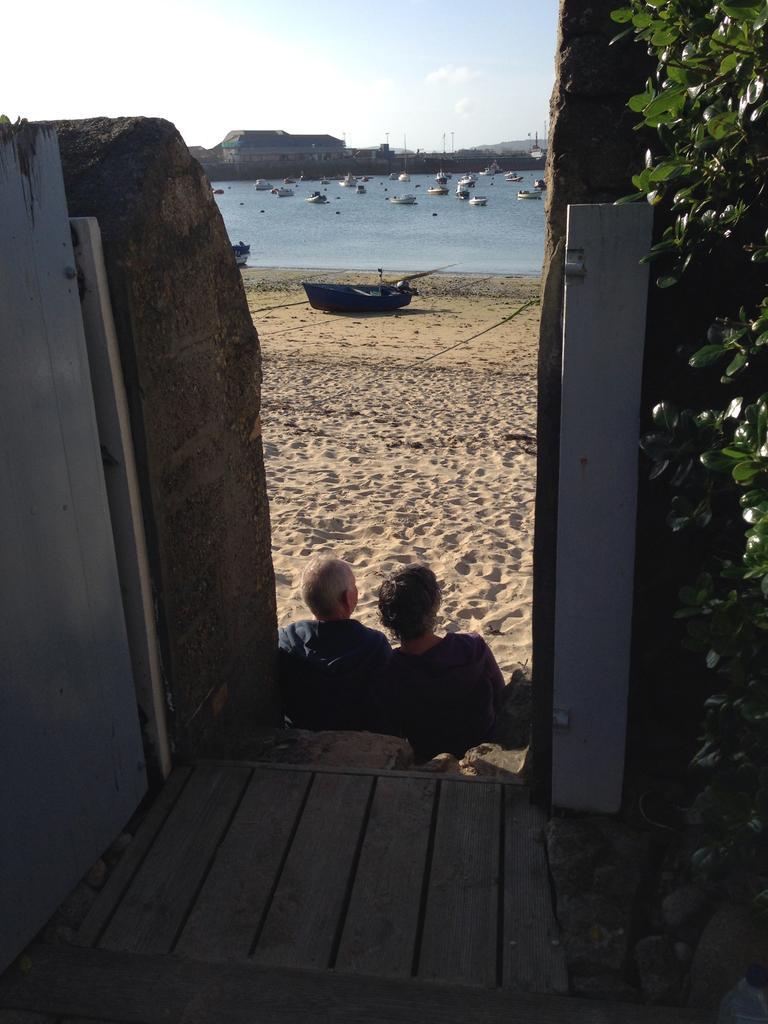Please provide a concise description of this image. In this image at the bottom, there are two people sitting. In the middle there are plants, sand, boat. At the top there are many boats, water, hills, sky and clouds. 